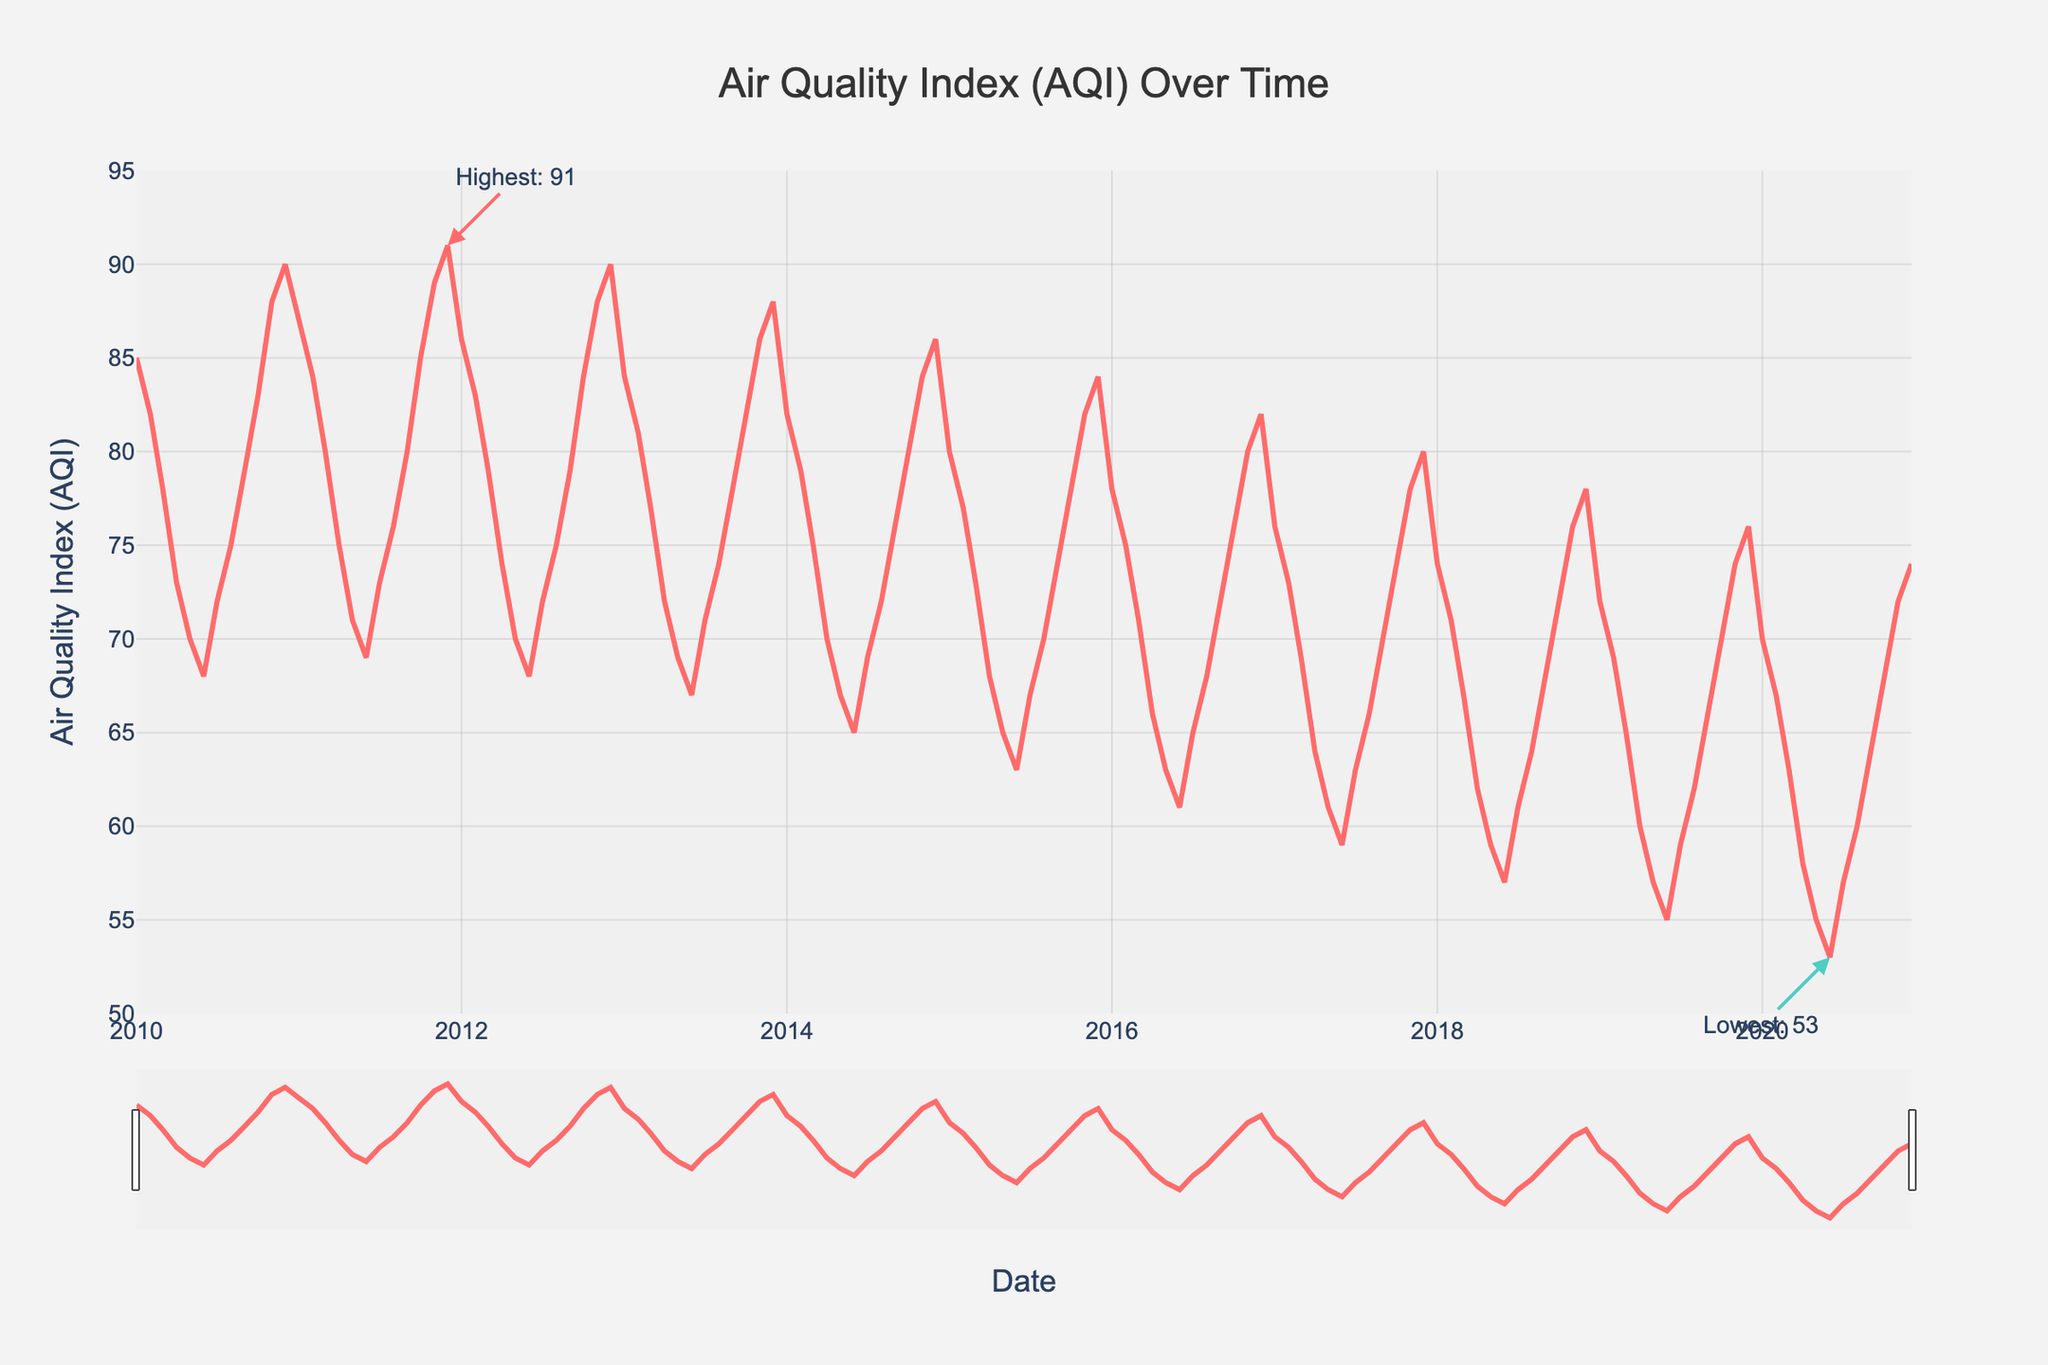What is the general trend in the Air Quality Index (AQI) over the decade? The general trend in AQI over the decade can be observed by looking at the line. It starts at around 85 in 2010 and shows a decreasing pattern, ending at around 70 in 2020. This indicates an overall improvement in air quality.
Answer: Decreasing In which year did the AQI reach its highest value and what was the value? The highest AQI can be found by looking for the peak in the line chart. The annotation marks the highest point, which occurred in December 2012 with an AQI of 91.
Answer: 2012, 91 How does the AQI in January 2010 compare to January 2020? Compare the height of the points in January 2010 and January 2020 on the x-axis. January 2010's AQI is 85, while January 2020's AQI is 70. Clearly, 2020’s January had a lower AQI, indicating better air quality.
Answer: January 2020 is lower What is the average monthly AQI for the year 2015? To find the average monthly AQI for 2015, add up all the AQI values for each month of 2015 and then divide by 12 (number of months). Sum = 80 + 77 + 73 + 68 + 65 + 63 + 67 + 70 + 74 + 78 + 82 + 84 = 881. Then, 881 / 12 = 73.42.
Answer: 73.42 Which month generally has the worst air quality on average over the decade? Look at the overall trend month by month over the ten years. December appears to consistently have higher AQI values compared to other months, indicating worse air quality.
Answer: December How does the AQI fluctuate within each year typically? Look at the line's movement within individual years. Generally, the AQI starts high in the early months, dips in the middle of the year (summer months), and rises again towards the end of the year.
Answer: High → Low → High What was the AQI for the month with the lowest recorded AQI over the decade and which month was it? Identify the lowest point in the chart using the annotation. The lowest AQI was recorded in June 2020 with a value of 53.
Answer: June 2020, 53 Compare the AQI of summer months (June, July, August) in 2010 and 2020. Which year had better air quality? Look at the AQI values for June, July, and August in 2010 (68, 72, 75) and 2020 (53, 57, 60). Summing them: 2010 = 68 + 72 + 75 = 215, 2020 = 53 + 57 + 60 = 170. Lower sum indicates better air quality in 2020.
Answer: 2020 had better air quality What is the difference in AQI between the highest (December 2012) and lowest (June 2020) recorded values? Subtract the lowest AQI value from the highest AQI value: 91 (December 2012) - 53 (June 2020) = 38.
Answer: 38 Is there a visible pattern in AQI changes throughout each year? Observe the repetitive up and down pattern in the AQI every year. Every year, the AQI tends to increase from January to winter months and decrease during summer.
Answer: Yes 